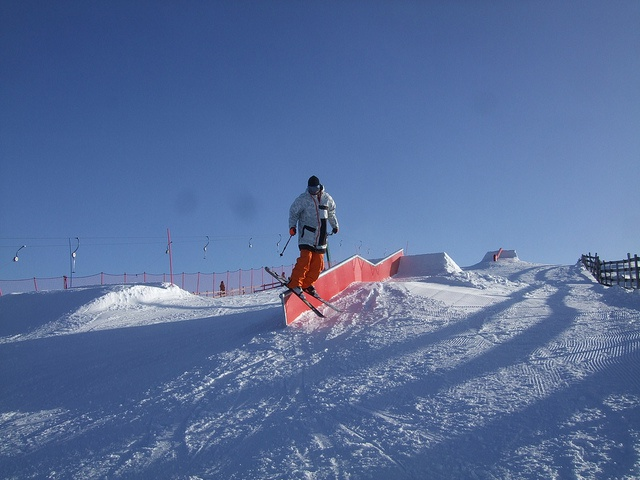Describe the objects in this image and their specific colors. I can see people in darkblue, gray, maroon, and black tones, skis in darkblue, black, gray, and darkgray tones, people in darkblue, maroon, purple, darkgray, and black tones, and people in darkblue, purple, and gray tones in this image. 